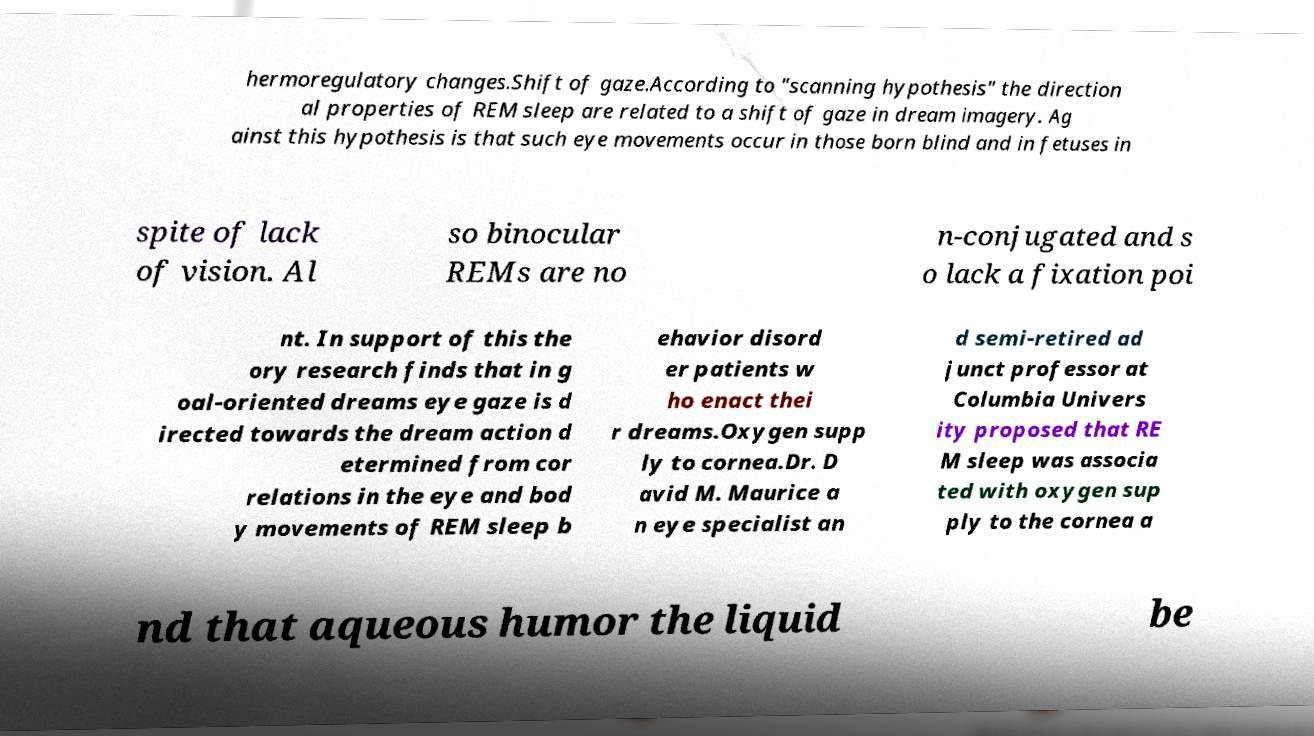There's text embedded in this image that I need extracted. Can you transcribe it verbatim? hermoregulatory changes.Shift of gaze.According to "scanning hypothesis" the direction al properties of REM sleep are related to a shift of gaze in dream imagery. Ag ainst this hypothesis is that such eye movements occur in those born blind and in fetuses in spite of lack of vision. Al so binocular REMs are no n-conjugated and s o lack a fixation poi nt. In support of this the ory research finds that in g oal-oriented dreams eye gaze is d irected towards the dream action d etermined from cor relations in the eye and bod y movements of REM sleep b ehavior disord er patients w ho enact thei r dreams.Oxygen supp ly to cornea.Dr. D avid M. Maurice a n eye specialist an d semi-retired ad junct professor at Columbia Univers ity proposed that RE M sleep was associa ted with oxygen sup ply to the cornea a nd that aqueous humor the liquid be 